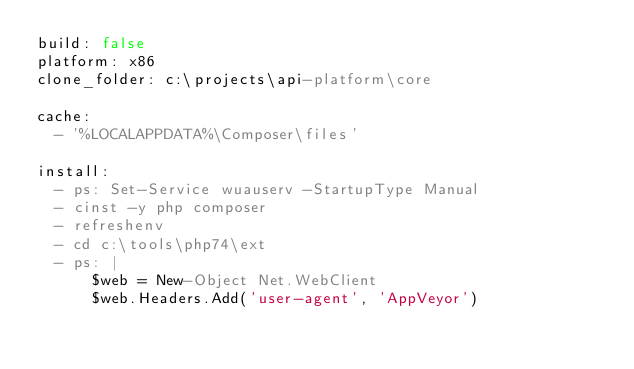<code> <loc_0><loc_0><loc_500><loc_500><_YAML_>build: false
platform: x86
clone_folder: c:\projects\api-platform\core

cache:
  - '%LOCALAPPDATA%\Composer\files'

install:
  - ps: Set-Service wuauserv -StartupType Manual
  - cinst -y php composer
  - refreshenv
  - cd c:\tools\php74\ext
  - ps: |
      $web = New-Object Net.WebClient
      $web.Headers.Add('user-agent', 'AppVeyor')</code> 